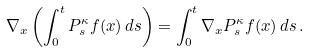Convert formula to latex. <formula><loc_0><loc_0><loc_500><loc_500>\nabla _ { x } \left ( \int _ { 0 } ^ { t } P ^ { \kappa } _ { s } f ( x ) \, d s \right ) = \int _ { 0 } ^ { t } \nabla _ { x } P ^ { \kappa } _ { s } f ( x ) \, d s \, .</formula> 